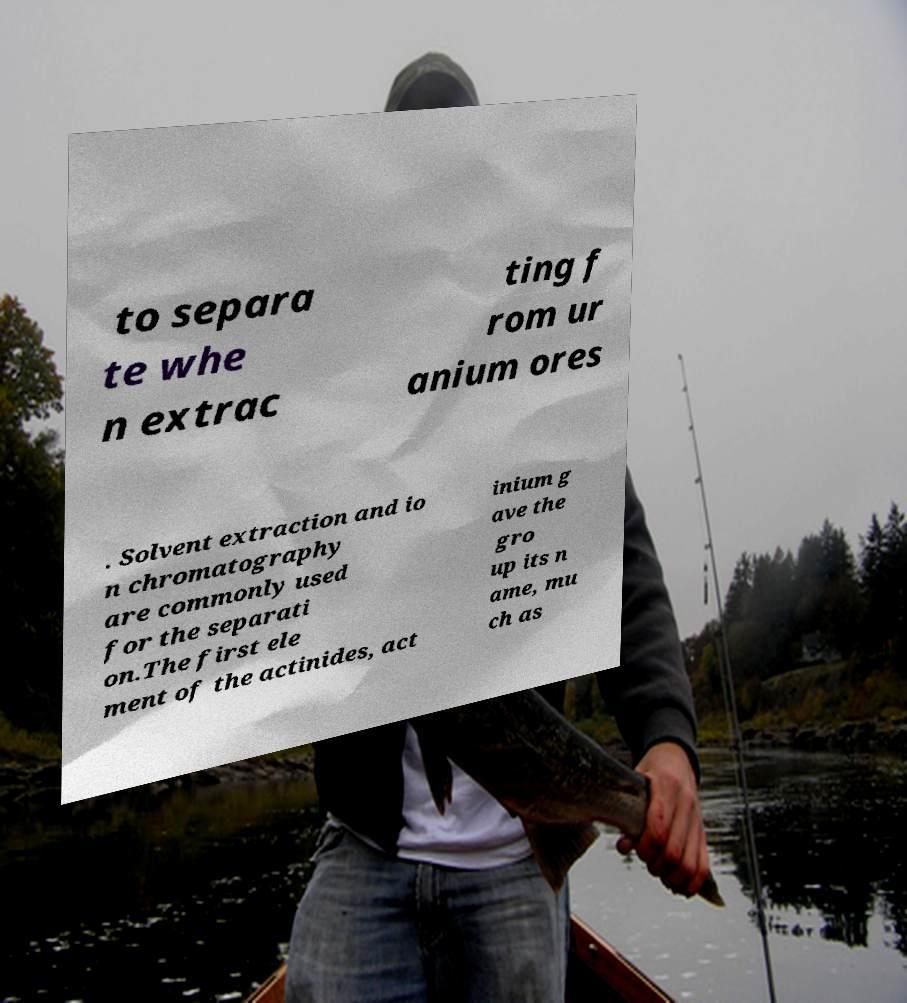There's text embedded in this image that I need extracted. Can you transcribe it verbatim? to separa te whe n extrac ting f rom ur anium ores . Solvent extraction and io n chromatography are commonly used for the separati on.The first ele ment of the actinides, act inium g ave the gro up its n ame, mu ch as 